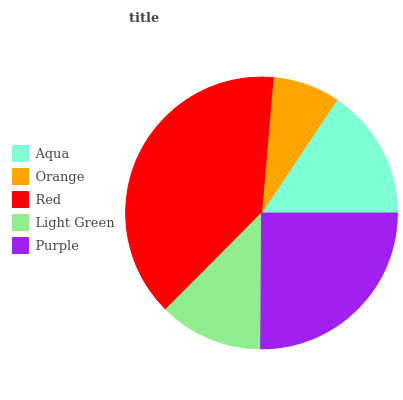Is Orange the minimum?
Answer yes or no. Yes. Is Red the maximum?
Answer yes or no. Yes. Is Red the minimum?
Answer yes or no. No. Is Orange the maximum?
Answer yes or no. No. Is Red greater than Orange?
Answer yes or no. Yes. Is Orange less than Red?
Answer yes or no. Yes. Is Orange greater than Red?
Answer yes or no. No. Is Red less than Orange?
Answer yes or no. No. Is Aqua the high median?
Answer yes or no. Yes. Is Aqua the low median?
Answer yes or no. Yes. Is Light Green the high median?
Answer yes or no. No. Is Red the low median?
Answer yes or no. No. 